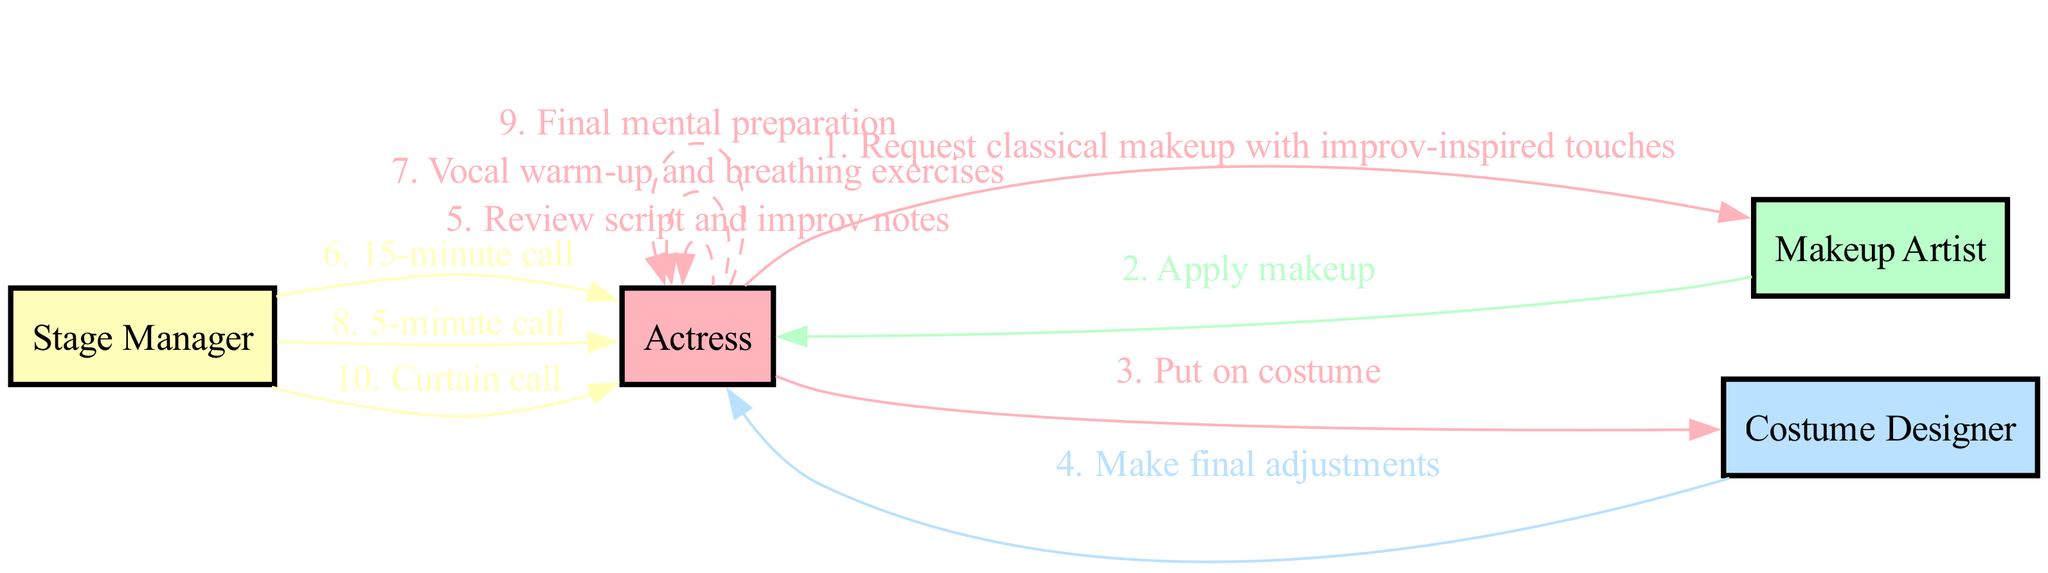What is the first action in the sequence? The first action is initiated by the Actress, where she requests classical makeup with improv-inspired touches from the Makeup Artist.
Answer: Request classical makeup with improv-inspired touches Who performs the final adjustments on the costume? The Costume Designer is responsible for making final adjustments on the costume after the Actress puts it on.
Answer: Costume Designer What is the action taken directly after the "15-minute call"? After receiving the "15-minute call" from the Stage Manager, the Actress performs vocal warm-up and breathing exercises.
Answer: Vocal warm-up and breathing exercises How many total nodes are present in the diagram? There are a total of four nodes in the diagram, representing the actors: Actress, Makeup Artist, Costume Designer, and Stage Manager.
Answer: 4 Which actor is involved in the "Curtain call"? The Curtain call action is directed from the Stage Manager to the Actress.
Answer: Stage Manager What action follows the Actress's "Final mental preparation"? After the Actress completes her "Final mental preparation," she receives the "Curtain call" from the Stage Manager.
Answer: Curtain call How many actions are taken by the Actress herself in the sequence? The Actress has three actions in the sequence: reviewing script and improv notes, performing vocal warm-up and breathing exercises, and the final mental preparation.
Answer: 3 What type of edge connects an action performed by an actor to themselves? The edges that connect an action performed by an actor to themselves are dashed and labeled accordingly, indicating self-actions.
Answer: Dashed What color represents the Makeup Artist in the diagram? The Makeup Artist is represented in a light green color, which is coded as #BAFFC9 in the diagram.
Answer: #BAFFC9 